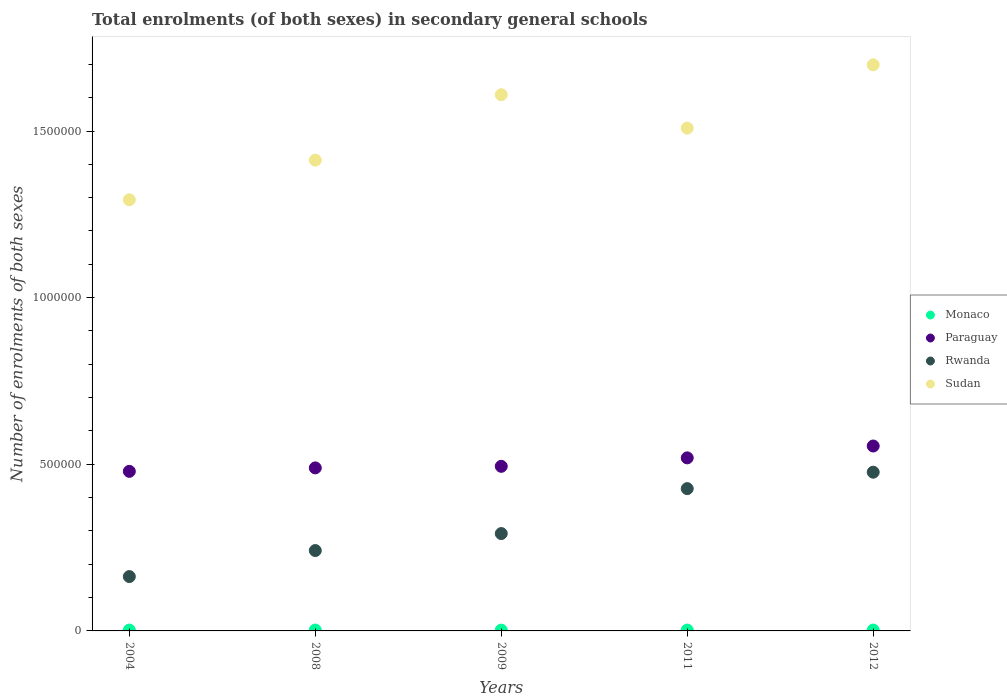How many different coloured dotlines are there?
Give a very brief answer. 4. What is the number of enrolments in secondary schools in Rwanda in 2012?
Offer a very short reply. 4.76e+05. Across all years, what is the maximum number of enrolments in secondary schools in Sudan?
Make the answer very short. 1.70e+06. Across all years, what is the minimum number of enrolments in secondary schools in Rwanda?
Your answer should be compact. 1.63e+05. In which year was the number of enrolments in secondary schools in Sudan minimum?
Your response must be concise. 2004. What is the total number of enrolments in secondary schools in Rwanda in the graph?
Ensure brevity in your answer.  1.60e+06. What is the difference between the number of enrolments in secondary schools in Sudan in 2004 and that in 2012?
Your answer should be very brief. -4.05e+05. What is the difference between the number of enrolments in secondary schools in Sudan in 2011 and the number of enrolments in secondary schools in Monaco in 2008?
Your answer should be compact. 1.51e+06. What is the average number of enrolments in secondary schools in Monaco per year?
Make the answer very short. 2590. In the year 2011, what is the difference between the number of enrolments in secondary schools in Paraguay and number of enrolments in secondary schools in Rwanda?
Ensure brevity in your answer.  9.23e+04. What is the ratio of the number of enrolments in secondary schools in Paraguay in 2004 to that in 2009?
Keep it short and to the point. 0.97. What is the difference between the highest and the second highest number of enrolments in secondary schools in Sudan?
Provide a short and direct response. 8.97e+04. What is the difference between the highest and the lowest number of enrolments in secondary schools in Rwanda?
Ensure brevity in your answer.  3.13e+05. In how many years, is the number of enrolments in secondary schools in Rwanda greater than the average number of enrolments in secondary schools in Rwanda taken over all years?
Your answer should be very brief. 2. Is it the case that in every year, the sum of the number of enrolments in secondary schools in Rwanda and number of enrolments in secondary schools in Monaco  is greater than the sum of number of enrolments in secondary schools in Sudan and number of enrolments in secondary schools in Paraguay?
Ensure brevity in your answer.  No. Is it the case that in every year, the sum of the number of enrolments in secondary schools in Rwanda and number of enrolments in secondary schools in Sudan  is greater than the number of enrolments in secondary schools in Paraguay?
Give a very brief answer. Yes. Does the number of enrolments in secondary schools in Paraguay monotonically increase over the years?
Provide a succinct answer. Yes. Are the values on the major ticks of Y-axis written in scientific E-notation?
Your response must be concise. No. What is the title of the graph?
Offer a very short reply. Total enrolments (of both sexes) in secondary general schools. Does "Benin" appear as one of the legend labels in the graph?
Provide a succinct answer. No. What is the label or title of the Y-axis?
Make the answer very short. Number of enrolments of both sexes. What is the Number of enrolments of both sexes in Monaco in 2004?
Provide a short and direct response. 2600. What is the Number of enrolments of both sexes of Paraguay in 2004?
Give a very brief answer. 4.79e+05. What is the Number of enrolments of both sexes of Rwanda in 2004?
Provide a succinct answer. 1.63e+05. What is the Number of enrolments of both sexes of Sudan in 2004?
Offer a terse response. 1.29e+06. What is the Number of enrolments of both sexes of Monaco in 2008?
Your answer should be very brief. 2643. What is the Number of enrolments of both sexes in Paraguay in 2008?
Provide a short and direct response. 4.89e+05. What is the Number of enrolments of both sexes of Rwanda in 2008?
Offer a very short reply. 2.41e+05. What is the Number of enrolments of both sexes in Sudan in 2008?
Give a very brief answer. 1.41e+06. What is the Number of enrolments of both sexes in Monaco in 2009?
Keep it short and to the point. 2440. What is the Number of enrolments of both sexes in Paraguay in 2009?
Offer a terse response. 4.94e+05. What is the Number of enrolments of both sexes in Rwanda in 2009?
Offer a very short reply. 2.92e+05. What is the Number of enrolments of both sexes of Sudan in 2009?
Provide a succinct answer. 1.61e+06. What is the Number of enrolments of both sexes in Monaco in 2011?
Your answer should be compact. 2610. What is the Number of enrolments of both sexes in Paraguay in 2011?
Offer a very short reply. 5.19e+05. What is the Number of enrolments of both sexes in Rwanda in 2011?
Keep it short and to the point. 4.27e+05. What is the Number of enrolments of both sexes in Sudan in 2011?
Your answer should be very brief. 1.51e+06. What is the Number of enrolments of both sexes of Monaco in 2012?
Offer a very short reply. 2657. What is the Number of enrolments of both sexes of Paraguay in 2012?
Your response must be concise. 5.55e+05. What is the Number of enrolments of both sexes in Rwanda in 2012?
Offer a terse response. 4.76e+05. What is the Number of enrolments of both sexes of Sudan in 2012?
Your answer should be very brief. 1.70e+06. Across all years, what is the maximum Number of enrolments of both sexes in Monaco?
Make the answer very short. 2657. Across all years, what is the maximum Number of enrolments of both sexes in Paraguay?
Keep it short and to the point. 5.55e+05. Across all years, what is the maximum Number of enrolments of both sexes of Rwanda?
Provide a short and direct response. 4.76e+05. Across all years, what is the maximum Number of enrolments of both sexes of Sudan?
Your response must be concise. 1.70e+06. Across all years, what is the minimum Number of enrolments of both sexes in Monaco?
Offer a very short reply. 2440. Across all years, what is the minimum Number of enrolments of both sexes of Paraguay?
Ensure brevity in your answer.  4.79e+05. Across all years, what is the minimum Number of enrolments of both sexes of Rwanda?
Make the answer very short. 1.63e+05. Across all years, what is the minimum Number of enrolments of both sexes of Sudan?
Make the answer very short. 1.29e+06. What is the total Number of enrolments of both sexes in Monaco in the graph?
Ensure brevity in your answer.  1.30e+04. What is the total Number of enrolments of both sexes in Paraguay in the graph?
Keep it short and to the point. 2.54e+06. What is the total Number of enrolments of both sexes in Rwanda in the graph?
Provide a short and direct response. 1.60e+06. What is the total Number of enrolments of both sexes of Sudan in the graph?
Provide a short and direct response. 7.52e+06. What is the difference between the Number of enrolments of both sexes of Monaco in 2004 and that in 2008?
Provide a short and direct response. -43. What is the difference between the Number of enrolments of both sexes in Paraguay in 2004 and that in 2008?
Make the answer very short. -1.04e+04. What is the difference between the Number of enrolments of both sexes of Rwanda in 2004 and that in 2008?
Ensure brevity in your answer.  -7.81e+04. What is the difference between the Number of enrolments of both sexes of Sudan in 2004 and that in 2008?
Your answer should be very brief. -1.19e+05. What is the difference between the Number of enrolments of both sexes in Monaco in 2004 and that in 2009?
Provide a short and direct response. 160. What is the difference between the Number of enrolments of both sexes of Paraguay in 2004 and that in 2009?
Keep it short and to the point. -1.51e+04. What is the difference between the Number of enrolments of both sexes of Rwanda in 2004 and that in 2009?
Provide a short and direct response. -1.29e+05. What is the difference between the Number of enrolments of both sexes in Sudan in 2004 and that in 2009?
Make the answer very short. -3.15e+05. What is the difference between the Number of enrolments of both sexes in Paraguay in 2004 and that in 2011?
Ensure brevity in your answer.  -4.05e+04. What is the difference between the Number of enrolments of both sexes of Rwanda in 2004 and that in 2011?
Give a very brief answer. -2.64e+05. What is the difference between the Number of enrolments of both sexes of Sudan in 2004 and that in 2011?
Offer a very short reply. -2.15e+05. What is the difference between the Number of enrolments of both sexes in Monaco in 2004 and that in 2012?
Ensure brevity in your answer.  -57. What is the difference between the Number of enrolments of both sexes of Paraguay in 2004 and that in 2012?
Your response must be concise. -7.60e+04. What is the difference between the Number of enrolments of both sexes of Rwanda in 2004 and that in 2012?
Provide a short and direct response. -3.13e+05. What is the difference between the Number of enrolments of both sexes in Sudan in 2004 and that in 2012?
Offer a terse response. -4.05e+05. What is the difference between the Number of enrolments of both sexes in Monaco in 2008 and that in 2009?
Your answer should be compact. 203. What is the difference between the Number of enrolments of both sexes in Paraguay in 2008 and that in 2009?
Ensure brevity in your answer.  -4696. What is the difference between the Number of enrolments of both sexes in Rwanda in 2008 and that in 2009?
Give a very brief answer. -5.10e+04. What is the difference between the Number of enrolments of both sexes of Sudan in 2008 and that in 2009?
Make the answer very short. -1.96e+05. What is the difference between the Number of enrolments of both sexes in Paraguay in 2008 and that in 2011?
Keep it short and to the point. -3.01e+04. What is the difference between the Number of enrolments of both sexes of Rwanda in 2008 and that in 2011?
Make the answer very short. -1.86e+05. What is the difference between the Number of enrolments of both sexes in Sudan in 2008 and that in 2011?
Ensure brevity in your answer.  -9.60e+04. What is the difference between the Number of enrolments of both sexes in Paraguay in 2008 and that in 2012?
Provide a succinct answer. -6.56e+04. What is the difference between the Number of enrolments of both sexes in Rwanda in 2008 and that in 2012?
Ensure brevity in your answer.  -2.35e+05. What is the difference between the Number of enrolments of both sexes in Sudan in 2008 and that in 2012?
Ensure brevity in your answer.  -2.86e+05. What is the difference between the Number of enrolments of both sexes of Monaco in 2009 and that in 2011?
Ensure brevity in your answer.  -170. What is the difference between the Number of enrolments of both sexes in Paraguay in 2009 and that in 2011?
Ensure brevity in your answer.  -2.54e+04. What is the difference between the Number of enrolments of both sexes in Rwanda in 2009 and that in 2011?
Offer a terse response. -1.35e+05. What is the difference between the Number of enrolments of both sexes of Sudan in 2009 and that in 2011?
Your answer should be very brief. 1.00e+05. What is the difference between the Number of enrolments of both sexes of Monaco in 2009 and that in 2012?
Make the answer very short. -217. What is the difference between the Number of enrolments of both sexes in Paraguay in 2009 and that in 2012?
Offer a terse response. -6.10e+04. What is the difference between the Number of enrolments of both sexes in Rwanda in 2009 and that in 2012?
Your response must be concise. -1.84e+05. What is the difference between the Number of enrolments of both sexes in Sudan in 2009 and that in 2012?
Provide a short and direct response. -8.97e+04. What is the difference between the Number of enrolments of both sexes of Monaco in 2011 and that in 2012?
Provide a succinct answer. -47. What is the difference between the Number of enrolments of both sexes in Paraguay in 2011 and that in 2012?
Keep it short and to the point. -3.56e+04. What is the difference between the Number of enrolments of both sexes of Rwanda in 2011 and that in 2012?
Make the answer very short. -4.93e+04. What is the difference between the Number of enrolments of both sexes of Sudan in 2011 and that in 2012?
Offer a very short reply. -1.90e+05. What is the difference between the Number of enrolments of both sexes in Monaco in 2004 and the Number of enrolments of both sexes in Paraguay in 2008?
Provide a short and direct response. -4.87e+05. What is the difference between the Number of enrolments of both sexes of Monaco in 2004 and the Number of enrolments of both sexes of Rwanda in 2008?
Provide a short and direct response. -2.39e+05. What is the difference between the Number of enrolments of both sexes in Monaco in 2004 and the Number of enrolments of both sexes in Sudan in 2008?
Make the answer very short. -1.41e+06. What is the difference between the Number of enrolments of both sexes in Paraguay in 2004 and the Number of enrolments of both sexes in Rwanda in 2008?
Provide a short and direct response. 2.38e+05. What is the difference between the Number of enrolments of both sexes of Paraguay in 2004 and the Number of enrolments of both sexes of Sudan in 2008?
Provide a short and direct response. -9.34e+05. What is the difference between the Number of enrolments of both sexes of Rwanda in 2004 and the Number of enrolments of both sexes of Sudan in 2008?
Your answer should be compact. -1.25e+06. What is the difference between the Number of enrolments of both sexes in Monaco in 2004 and the Number of enrolments of both sexes in Paraguay in 2009?
Keep it short and to the point. -4.91e+05. What is the difference between the Number of enrolments of both sexes of Monaco in 2004 and the Number of enrolments of both sexes of Rwanda in 2009?
Provide a short and direct response. -2.90e+05. What is the difference between the Number of enrolments of both sexes in Monaco in 2004 and the Number of enrolments of both sexes in Sudan in 2009?
Your answer should be very brief. -1.61e+06. What is the difference between the Number of enrolments of both sexes of Paraguay in 2004 and the Number of enrolments of both sexes of Rwanda in 2009?
Make the answer very short. 1.87e+05. What is the difference between the Number of enrolments of both sexes in Paraguay in 2004 and the Number of enrolments of both sexes in Sudan in 2009?
Give a very brief answer. -1.13e+06. What is the difference between the Number of enrolments of both sexes of Rwanda in 2004 and the Number of enrolments of both sexes of Sudan in 2009?
Give a very brief answer. -1.45e+06. What is the difference between the Number of enrolments of both sexes of Monaco in 2004 and the Number of enrolments of both sexes of Paraguay in 2011?
Make the answer very short. -5.17e+05. What is the difference between the Number of enrolments of both sexes in Monaco in 2004 and the Number of enrolments of both sexes in Rwanda in 2011?
Keep it short and to the point. -4.24e+05. What is the difference between the Number of enrolments of both sexes in Monaco in 2004 and the Number of enrolments of both sexes in Sudan in 2011?
Your answer should be very brief. -1.51e+06. What is the difference between the Number of enrolments of both sexes in Paraguay in 2004 and the Number of enrolments of both sexes in Rwanda in 2011?
Your response must be concise. 5.18e+04. What is the difference between the Number of enrolments of both sexes of Paraguay in 2004 and the Number of enrolments of both sexes of Sudan in 2011?
Your response must be concise. -1.03e+06. What is the difference between the Number of enrolments of both sexes of Rwanda in 2004 and the Number of enrolments of both sexes of Sudan in 2011?
Your answer should be very brief. -1.35e+06. What is the difference between the Number of enrolments of both sexes of Monaco in 2004 and the Number of enrolments of both sexes of Paraguay in 2012?
Offer a very short reply. -5.52e+05. What is the difference between the Number of enrolments of both sexes in Monaco in 2004 and the Number of enrolments of both sexes in Rwanda in 2012?
Offer a very short reply. -4.74e+05. What is the difference between the Number of enrolments of both sexes in Monaco in 2004 and the Number of enrolments of both sexes in Sudan in 2012?
Offer a very short reply. -1.70e+06. What is the difference between the Number of enrolments of both sexes in Paraguay in 2004 and the Number of enrolments of both sexes in Rwanda in 2012?
Make the answer very short. 2506. What is the difference between the Number of enrolments of both sexes in Paraguay in 2004 and the Number of enrolments of both sexes in Sudan in 2012?
Give a very brief answer. -1.22e+06. What is the difference between the Number of enrolments of both sexes of Rwanda in 2004 and the Number of enrolments of both sexes of Sudan in 2012?
Make the answer very short. -1.54e+06. What is the difference between the Number of enrolments of both sexes in Monaco in 2008 and the Number of enrolments of both sexes in Paraguay in 2009?
Keep it short and to the point. -4.91e+05. What is the difference between the Number of enrolments of both sexes in Monaco in 2008 and the Number of enrolments of both sexes in Rwanda in 2009?
Offer a very short reply. -2.89e+05. What is the difference between the Number of enrolments of both sexes in Monaco in 2008 and the Number of enrolments of both sexes in Sudan in 2009?
Your answer should be very brief. -1.61e+06. What is the difference between the Number of enrolments of both sexes of Paraguay in 2008 and the Number of enrolments of both sexes of Rwanda in 2009?
Your answer should be compact. 1.97e+05. What is the difference between the Number of enrolments of both sexes of Paraguay in 2008 and the Number of enrolments of both sexes of Sudan in 2009?
Ensure brevity in your answer.  -1.12e+06. What is the difference between the Number of enrolments of both sexes of Rwanda in 2008 and the Number of enrolments of both sexes of Sudan in 2009?
Your answer should be very brief. -1.37e+06. What is the difference between the Number of enrolments of both sexes of Monaco in 2008 and the Number of enrolments of both sexes of Paraguay in 2011?
Offer a very short reply. -5.17e+05. What is the difference between the Number of enrolments of both sexes of Monaco in 2008 and the Number of enrolments of both sexes of Rwanda in 2011?
Your answer should be compact. -4.24e+05. What is the difference between the Number of enrolments of both sexes in Monaco in 2008 and the Number of enrolments of both sexes in Sudan in 2011?
Make the answer very short. -1.51e+06. What is the difference between the Number of enrolments of both sexes of Paraguay in 2008 and the Number of enrolments of both sexes of Rwanda in 2011?
Your answer should be very brief. 6.22e+04. What is the difference between the Number of enrolments of both sexes in Paraguay in 2008 and the Number of enrolments of both sexes in Sudan in 2011?
Make the answer very short. -1.02e+06. What is the difference between the Number of enrolments of both sexes of Rwanda in 2008 and the Number of enrolments of both sexes of Sudan in 2011?
Give a very brief answer. -1.27e+06. What is the difference between the Number of enrolments of both sexes in Monaco in 2008 and the Number of enrolments of both sexes in Paraguay in 2012?
Provide a short and direct response. -5.52e+05. What is the difference between the Number of enrolments of both sexes of Monaco in 2008 and the Number of enrolments of both sexes of Rwanda in 2012?
Keep it short and to the point. -4.74e+05. What is the difference between the Number of enrolments of both sexes in Monaco in 2008 and the Number of enrolments of both sexes in Sudan in 2012?
Your response must be concise. -1.70e+06. What is the difference between the Number of enrolments of both sexes in Paraguay in 2008 and the Number of enrolments of both sexes in Rwanda in 2012?
Offer a terse response. 1.29e+04. What is the difference between the Number of enrolments of both sexes of Paraguay in 2008 and the Number of enrolments of both sexes of Sudan in 2012?
Provide a succinct answer. -1.21e+06. What is the difference between the Number of enrolments of both sexes of Rwanda in 2008 and the Number of enrolments of both sexes of Sudan in 2012?
Offer a very short reply. -1.46e+06. What is the difference between the Number of enrolments of both sexes in Monaco in 2009 and the Number of enrolments of both sexes in Paraguay in 2011?
Your answer should be compact. -5.17e+05. What is the difference between the Number of enrolments of both sexes in Monaco in 2009 and the Number of enrolments of both sexes in Rwanda in 2011?
Your answer should be compact. -4.25e+05. What is the difference between the Number of enrolments of both sexes in Monaco in 2009 and the Number of enrolments of both sexes in Sudan in 2011?
Provide a short and direct response. -1.51e+06. What is the difference between the Number of enrolments of both sexes of Paraguay in 2009 and the Number of enrolments of both sexes of Rwanda in 2011?
Provide a short and direct response. 6.69e+04. What is the difference between the Number of enrolments of both sexes in Paraguay in 2009 and the Number of enrolments of both sexes in Sudan in 2011?
Offer a terse response. -1.01e+06. What is the difference between the Number of enrolments of both sexes of Rwanda in 2009 and the Number of enrolments of both sexes of Sudan in 2011?
Offer a terse response. -1.22e+06. What is the difference between the Number of enrolments of both sexes of Monaco in 2009 and the Number of enrolments of both sexes of Paraguay in 2012?
Your response must be concise. -5.52e+05. What is the difference between the Number of enrolments of both sexes of Monaco in 2009 and the Number of enrolments of both sexes of Rwanda in 2012?
Give a very brief answer. -4.74e+05. What is the difference between the Number of enrolments of both sexes of Monaco in 2009 and the Number of enrolments of both sexes of Sudan in 2012?
Your answer should be very brief. -1.70e+06. What is the difference between the Number of enrolments of both sexes in Paraguay in 2009 and the Number of enrolments of both sexes in Rwanda in 2012?
Keep it short and to the point. 1.76e+04. What is the difference between the Number of enrolments of both sexes in Paraguay in 2009 and the Number of enrolments of both sexes in Sudan in 2012?
Ensure brevity in your answer.  -1.20e+06. What is the difference between the Number of enrolments of both sexes of Rwanda in 2009 and the Number of enrolments of both sexes of Sudan in 2012?
Your response must be concise. -1.41e+06. What is the difference between the Number of enrolments of both sexes of Monaco in 2011 and the Number of enrolments of both sexes of Paraguay in 2012?
Your answer should be compact. -5.52e+05. What is the difference between the Number of enrolments of both sexes in Monaco in 2011 and the Number of enrolments of both sexes in Rwanda in 2012?
Offer a very short reply. -4.74e+05. What is the difference between the Number of enrolments of both sexes of Monaco in 2011 and the Number of enrolments of both sexes of Sudan in 2012?
Your answer should be compact. -1.70e+06. What is the difference between the Number of enrolments of both sexes of Paraguay in 2011 and the Number of enrolments of both sexes of Rwanda in 2012?
Make the answer very short. 4.30e+04. What is the difference between the Number of enrolments of both sexes of Paraguay in 2011 and the Number of enrolments of both sexes of Sudan in 2012?
Offer a very short reply. -1.18e+06. What is the difference between the Number of enrolments of both sexes of Rwanda in 2011 and the Number of enrolments of both sexes of Sudan in 2012?
Keep it short and to the point. -1.27e+06. What is the average Number of enrolments of both sexes in Monaco per year?
Keep it short and to the point. 2590. What is the average Number of enrolments of both sexes of Paraguay per year?
Make the answer very short. 5.07e+05. What is the average Number of enrolments of both sexes of Rwanda per year?
Provide a succinct answer. 3.20e+05. What is the average Number of enrolments of both sexes in Sudan per year?
Give a very brief answer. 1.50e+06. In the year 2004, what is the difference between the Number of enrolments of both sexes of Monaco and Number of enrolments of both sexes of Paraguay?
Make the answer very short. -4.76e+05. In the year 2004, what is the difference between the Number of enrolments of both sexes in Monaco and Number of enrolments of both sexes in Rwanda?
Give a very brief answer. -1.60e+05. In the year 2004, what is the difference between the Number of enrolments of both sexes of Monaco and Number of enrolments of both sexes of Sudan?
Offer a terse response. -1.29e+06. In the year 2004, what is the difference between the Number of enrolments of both sexes in Paraguay and Number of enrolments of both sexes in Rwanda?
Make the answer very short. 3.16e+05. In the year 2004, what is the difference between the Number of enrolments of both sexes in Paraguay and Number of enrolments of both sexes in Sudan?
Offer a very short reply. -8.15e+05. In the year 2004, what is the difference between the Number of enrolments of both sexes in Rwanda and Number of enrolments of both sexes in Sudan?
Offer a terse response. -1.13e+06. In the year 2008, what is the difference between the Number of enrolments of both sexes in Monaco and Number of enrolments of both sexes in Paraguay?
Ensure brevity in your answer.  -4.87e+05. In the year 2008, what is the difference between the Number of enrolments of both sexes of Monaco and Number of enrolments of both sexes of Rwanda?
Ensure brevity in your answer.  -2.38e+05. In the year 2008, what is the difference between the Number of enrolments of both sexes of Monaco and Number of enrolments of both sexes of Sudan?
Your answer should be very brief. -1.41e+06. In the year 2008, what is the difference between the Number of enrolments of both sexes of Paraguay and Number of enrolments of both sexes of Rwanda?
Provide a short and direct response. 2.48e+05. In the year 2008, what is the difference between the Number of enrolments of both sexes in Paraguay and Number of enrolments of both sexes in Sudan?
Give a very brief answer. -9.23e+05. In the year 2008, what is the difference between the Number of enrolments of both sexes in Rwanda and Number of enrolments of both sexes in Sudan?
Ensure brevity in your answer.  -1.17e+06. In the year 2009, what is the difference between the Number of enrolments of both sexes of Monaco and Number of enrolments of both sexes of Paraguay?
Make the answer very short. -4.91e+05. In the year 2009, what is the difference between the Number of enrolments of both sexes of Monaco and Number of enrolments of both sexes of Rwanda?
Ensure brevity in your answer.  -2.90e+05. In the year 2009, what is the difference between the Number of enrolments of both sexes of Monaco and Number of enrolments of both sexes of Sudan?
Offer a terse response. -1.61e+06. In the year 2009, what is the difference between the Number of enrolments of both sexes of Paraguay and Number of enrolments of both sexes of Rwanda?
Your answer should be compact. 2.02e+05. In the year 2009, what is the difference between the Number of enrolments of both sexes in Paraguay and Number of enrolments of both sexes in Sudan?
Provide a short and direct response. -1.11e+06. In the year 2009, what is the difference between the Number of enrolments of both sexes of Rwanda and Number of enrolments of both sexes of Sudan?
Offer a very short reply. -1.32e+06. In the year 2011, what is the difference between the Number of enrolments of both sexes in Monaco and Number of enrolments of both sexes in Paraguay?
Give a very brief answer. -5.17e+05. In the year 2011, what is the difference between the Number of enrolments of both sexes of Monaco and Number of enrolments of both sexes of Rwanda?
Provide a short and direct response. -4.24e+05. In the year 2011, what is the difference between the Number of enrolments of both sexes of Monaco and Number of enrolments of both sexes of Sudan?
Your answer should be compact. -1.51e+06. In the year 2011, what is the difference between the Number of enrolments of both sexes of Paraguay and Number of enrolments of both sexes of Rwanda?
Your answer should be very brief. 9.23e+04. In the year 2011, what is the difference between the Number of enrolments of both sexes in Paraguay and Number of enrolments of both sexes in Sudan?
Your answer should be very brief. -9.89e+05. In the year 2011, what is the difference between the Number of enrolments of both sexes of Rwanda and Number of enrolments of both sexes of Sudan?
Give a very brief answer. -1.08e+06. In the year 2012, what is the difference between the Number of enrolments of both sexes in Monaco and Number of enrolments of both sexes in Paraguay?
Provide a short and direct response. -5.52e+05. In the year 2012, what is the difference between the Number of enrolments of both sexes of Monaco and Number of enrolments of both sexes of Rwanda?
Keep it short and to the point. -4.74e+05. In the year 2012, what is the difference between the Number of enrolments of both sexes in Monaco and Number of enrolments of both sexes in Sudan?
Your answer should be very brief. -1.70e+06. In the year 2012, what is the difference between the Number of enrolments of both sexes of Paraguay and Number of enrolments of both sexes of Rwanda?
Offer a terse response. 7.85e+04. In the year 2012, what is the difference between the Number of enrolments of both sexes in Paraguay and Number of enrolments of both sexes in Sudan?
Make the answer very short. -1.14e+06. In the year 2012, what is the difference between the Number of enrolments of both sexes in Rwanda and Number of enrolments of both sexes in Sudan?
Provide a short and direct response. -1.22e+06. What is the ratio of the Number of enrolments of both sexes in Monaco in 2004 to that in 2008?
Offer a very short reply. 0.98. What is the ratio of the Number of enrolments of both sexes of Paraguay in 2004 to that in 2008?
Ensure brevity in your answer.  0.98. What is the ratio of the Number of enrolments of both sexes of Rwanda in 2004 to that in 2008?
Offer a terse response. 0.68. What is the ratio of the Number of enrolments of both sexes in Sudan in 2004 to that in 2008?
Give a very brief answer. 0.92. What is the ratio of the Number of enrolments of both sexes in Monaco in 2004 to that in 2009?
Make the answer very short. 1.07. What is the ratio of the Number of enrolments of both sexes in Paraguay in 2004 to that in 2009?
Offer a very short reply. 0.97. What is the ratio of the Number of enrolments of both sexes in Rwanda in 2004 to that in 2009?
Your answer should be very brief. 0.56. What is the ratio of the Number of enrolments of both sexes in Sudan in 2004 to that in 2009?
Give a very brief answer. 0.8. What is the ratio of the Number of enrolments of both sexes in Monaco in 2004 to that in 2011?
Offer a very short reply. 1. What is the ratio of the Number of enrolments of both sexes of Paraguay in 2004 to that in 2011?
Your response must be concise. 0.92. What is the ratio of the Number of enrolments of both sexes in Rwanda in 2004 to that in 2011?
Keep it short and to the point. 0.38. What is the ratio of the Number of enrolments of both sexes in Sudan in 2004 to that in 2011?
Make the answer very short. 0.86. What is the ratio of the Number of enrolments of both sexes of Monaco in 2004 to that in 2012?
Give a very brief answer. 0.98. What is the ratio of the Number of enrolments of both sexes of Paraguay in 2004 to that in 2012?
Ensure brevity in your answer.  0.86. What is the ratio of the Number of enrolments of both sexes in Rwanda in 2004 to that in 2012?
Give a very brief answer. 0.34. What is the ratio of the Number of enrolments of both sexes of Sudan in 2004 to that in 2012?
Your answer should be very brief. 0.76. What is the ratio of the Number of enrolments of both sexes in Monaco in 2008 to that in 2009?
Your response must be concise. 1.08. What is the ratio of the Number of enrolments of both sexes in Rwanda in 2008 to that in 2009?
Give a very brief answer. 0.83. What is the ratio of the Number of enrolments of both sexes of Sudan in 2008 to that in 2009?
Provide a succinct answer. 0.88. What is the ratio of the Number of enrolments of both sexes in Monaco in 2008 to that in 2011?
Your response must be concise. 1.01. What is the ratio of the Number of enrolments of both sexes of Paraguay in 2008 to that in 2011?
Ensure brevity in your answer.  0.94. What is the ratio of the Number of enrolments of both sexes in Rwanda in 2008 to that in 2011?
Make the answer very short. 0.56. What is the ratio of the Number of enrolments of both sexes in Sudan in 2008 to that in 2011?
Offer a terse response. 0.94. What is the ratio of the Number of enrolments of both sexes of Monaco in 2008 to that in 2012?
Offer a terse response. 0.99. What is the ratio of the Number of enrolments of both sexes in Paraguay in 2008 to that in 2012?
Offer a terse response. 0.88. What is the ratio of the Number of enrolments of both sexes in Rwanda in 2008 to that in 2012?
Your answer should be compact. 0.51. What is the ratio of the Number of enrolments of both sexes in Sudan in 2008 to that in 2012?
Make the answer very short. 0.83. What is the ratio of the Number of enrolments of both sexes in Monaco in 2009 to that in 2011?
Your response must be concise. 0.93. What is the ratio of the Number of enrolments of both sexes in Paraguay in 2009 to that in 2011?
Your answer should be compact. 0.95. What is the ratio of the Number of enrolments of both sexes in Rwanda in 2009 to that in 2011?
Offer a very short reply. 0.68. What is the ratio of the Number of enrolments of both sexes of Sudan in 2009 to that in 2011?
Offer a very short reply. 1.07. What is the ratio of the Number of enrolments of both sexes of Monaco in 2009 to that in 2012?
Your answer should be very brief. 0.92. What is the ratio of the Number of enrolments of both sexes in Paraguay in 2009 to that in 2012?
Offer a terse response. 0.89. What is the ratio of the Number of enrolments of both sexes in Rwanda in 2009 to that in 2012?
Offer a terse response. 0.61. What is the ratio of the Number of enrolments of both sexes of Sudan in 2009 to that in 2012?
Give a very brief answer. 0.95. What is the ratio of the Number of enrolments of both sexes in Monaco in 2011 to that in 2012?
Offer a terse response. 0.98. What is the ratio of the Number of enrolments of both sexes in Paraguay in 2011 to that in 2012?
Provide a short and direct response. 0.94. What is the ratio of the Number of enrolments of both sexes in Rwanda in 2011 to that in 2012?
Give a very brief answer. 0.9. What is the ratio of the Number of enrolments of both sexes in Sudan in 2011 to that in 2012?
Ensure brevity in your answer.  0.89. What is the difference between the highest and the second highest Number of enrolments of both sexes of Monaco?
Give a very brief answer. 14. What is the difference between the highest and the second highest Number of enrolments of both sexes in Paraguay?
Your answer should be very brief. 3.56e+04. What is the difference between the highest and the second highest Number of enrolments of both sexes in Rwanda?
Keep it short and to the point. 4.93e+04. What is the difference between the highest and the second highest Number of enrolments of both sexes in Sudan?
Offer a terse response. 8.97e+04. What is the difference between the highest and the lowest Number of enrolments of both sexes in Monaco?
Your answer should be very brief. 217. What is the difference between the highest and the lowest Number of enrolments of both sexes of Paraguay?
Provide a short and direct response. 7.60e+04. What is the difference between the highest and the lowest Number of enrolments of both sexes in Rwanda?
Ensure brevity in your answer.  3.13e+05. What is the difference between the highest and the lowest Number of enrolments of both sexes in Sudan?
Your answer should be compact. 4.05e+05. 